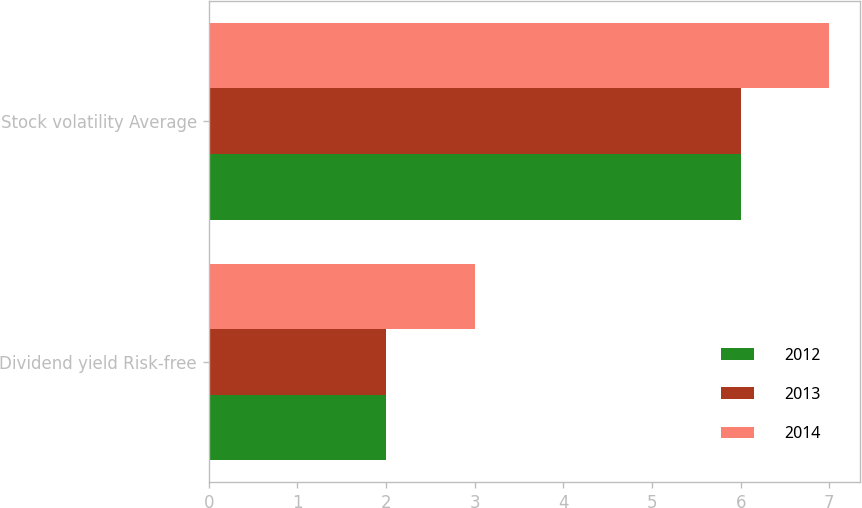Convert chart to OTSL. <chart><loc_0><loc_0><loc_500><loc_500><stacked_bar_chart><ecel><fcel>Dividend yield Risk-free<fcel>Stock volatility Average<nl><fcel>2012<fcel>2<fcel>6<nl><fcel>2013<fcel>2<fcel>6<nl><fcel>2014<fcel>3<fcel>7<nl></chart> 